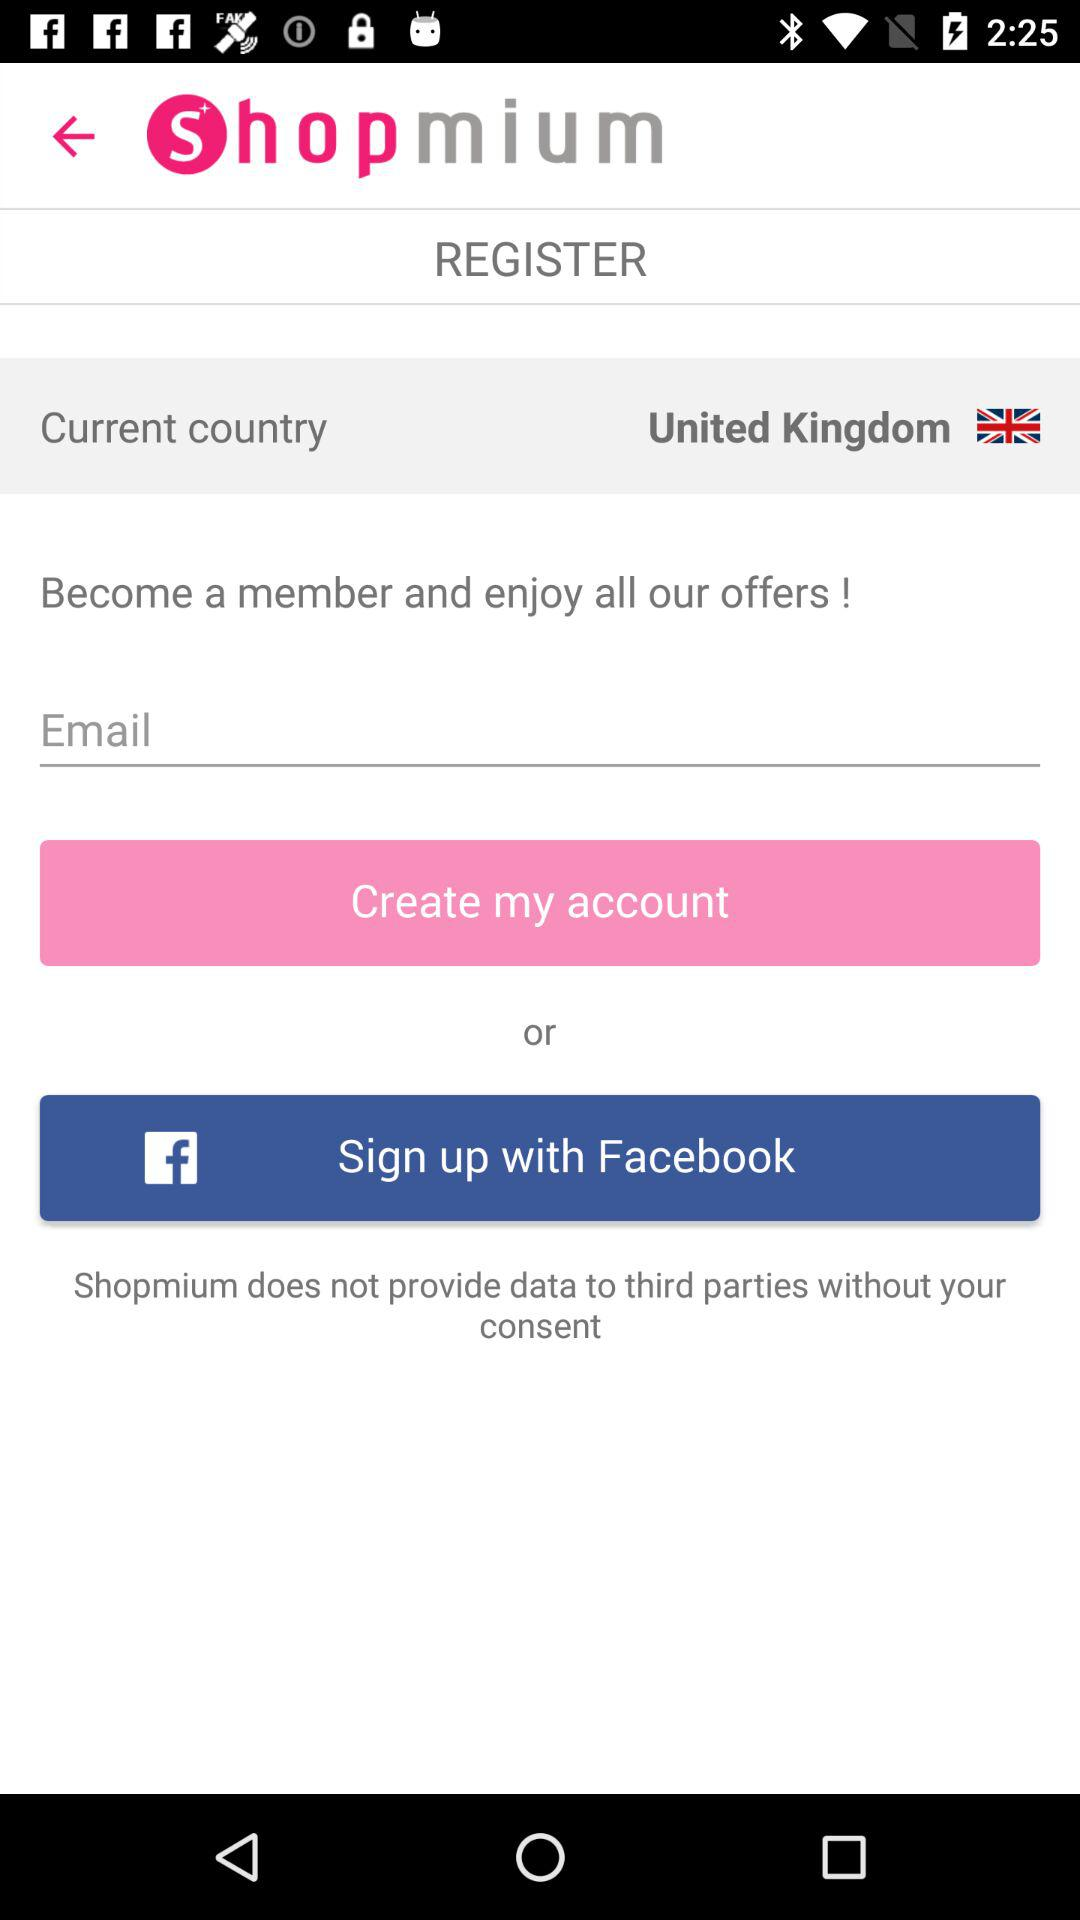What option is available for signing up? The available option is "Facebook". 